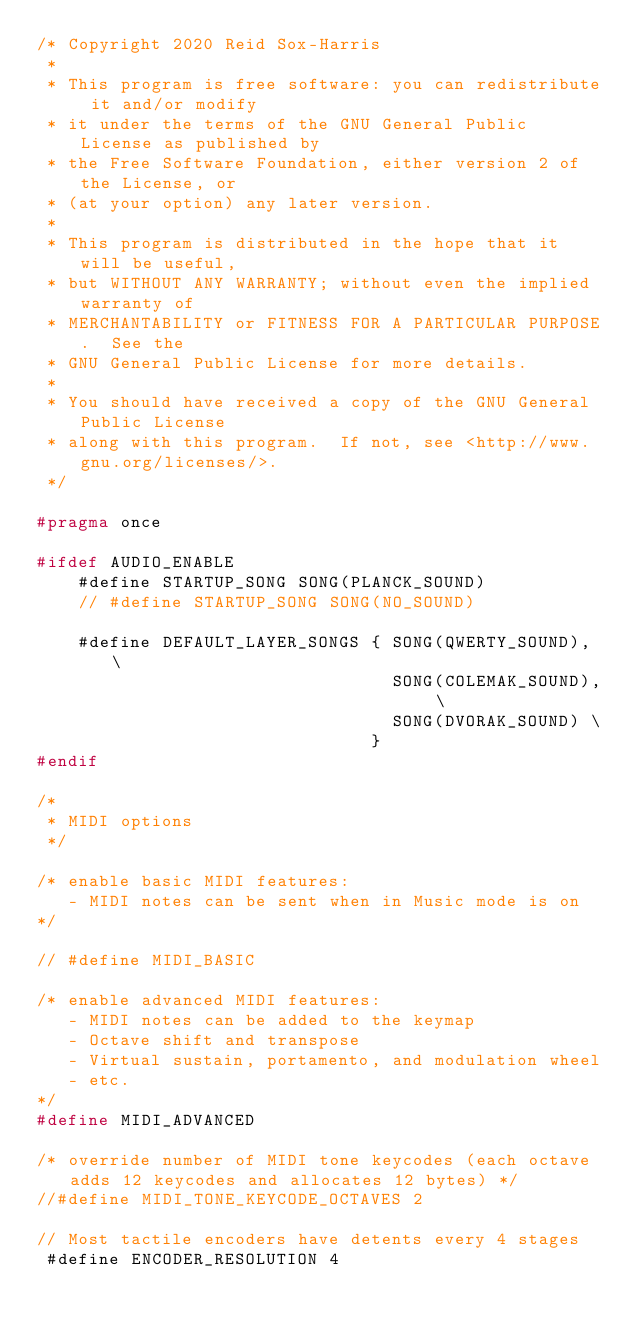Convert code to text. <code><loc_0><loc_0><loc_500><loc_500><_C_>/* Copyright 2020 Reid Sox-Harris
 *
 * This program is free software: you can redistribute it and/or modify
 * it under the terms of the GNU General Public License as published by
 * the Free Software Foundation, either version 2 of the License, or
 * (at your option) any later version.
 *
 * This program is distributed in the hope that it will be useful,
 * but WITHOUT ANY WARRANTY; without even the implied warranty of
 * MERCHANTABILITY or FITNESS FOR A PARTICULAR PURPOSE.  See the
 * GNU General Public License for more details.
 *
 * You should have received a copy of the GNU General Public License
 * along with this program.  If not, see <http://www.gnu.org/licenses/>.
 */

#pragma once

#ifdef AUDIO_ENABLE
    #define STARTUP_SONG SONG(PLANCK_SOUND)
    // #define STARTUP_SONG SONG(NO_SOUND)

    #define DEFAULT_LAYER_SONGS { SONG(QWERTY_SOUND), \
                                  SONG(COLEMAK_SOUND), \
                                  SONG(DVORAK_SOUND) \
                                }
#endif

/*
 * MIDI options
 */

/* enable basic MIDI features:
   - MIDI notes can be sent when in Music mode is on
*/

// #define MIDI_BASIC

/* enable advanced MIDI features:
   - MIDI notes can be added to the keymap
   - Octave shift and transpose
   - Virtual sustain, portamento, and modulation wheel
   - etc.
*/
#define MIDI_ADVANCED

/* override number of MIDI tone keycodes (each octave adds 12 keycodes and allocates 12 bytes) */
//#define MIDI_TONE_KEYCODE_OCTAVES 2

// Most tactile encoders have detents every 4 stages
 #define ENCODER_RESOLUTION 4

</code> 